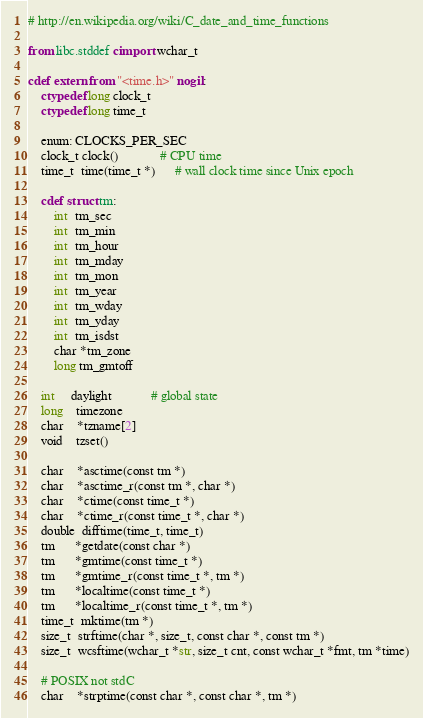<code> <loc_0><loc_0><loc_500><loc_500><_Cython_># http://en.wikipedia.org/wiki/C_date_and_time_functions

from libc.stddef cimport wchar_t

cdef extern from "<time.h>" nogil:
    ctypedef long clock_t
    ctypedef long time_t

    enum: CLOCKS_PER_SEC
    clock_t clock()             # CPU time
    time_t  time(time_t *)      # wall clock time since Unix epoch

    cdef struct tm:
        int  tm_sec
        int  tm_min
        int  tm_hour
        int  tm_mday
        int  tm_mon
        int  tm_year
        int  tm_wday
        int  tm_yday
        int  tm_isdst
        char *tm_zone
        long tm_gmtoff

    int     daylight            # global state
    long    timezone
    char    *tzname[2]
    void    tzset()

    char    *asctime(const tm *)
    char    *asctime_r(const tm *, char *)
    char    *ctime(const time_t *)
    char    *ctime_r(const time_t *, char *)
    double  difftime(time_t, time_t)
    tm      *getdate(const char *)
    tm      *gmtime(const time_t *)
    tm      *gmtime_r(const time_t *, tm *)
    tm      *localtime(const time_t *)
    tm      *localtime_r(const time_t *, tm *)
    time_t  mktime(tm *)
    size_t  strftime(char *, size_t, const char *, const tm *)
    size_t  wcsftime(wchar_t *str, size_t cnt, const wchar_t *fmt, tm *time)

    # POSIX not stdC
    char    *strptime(const char *, const char *, tm *)
</code> 